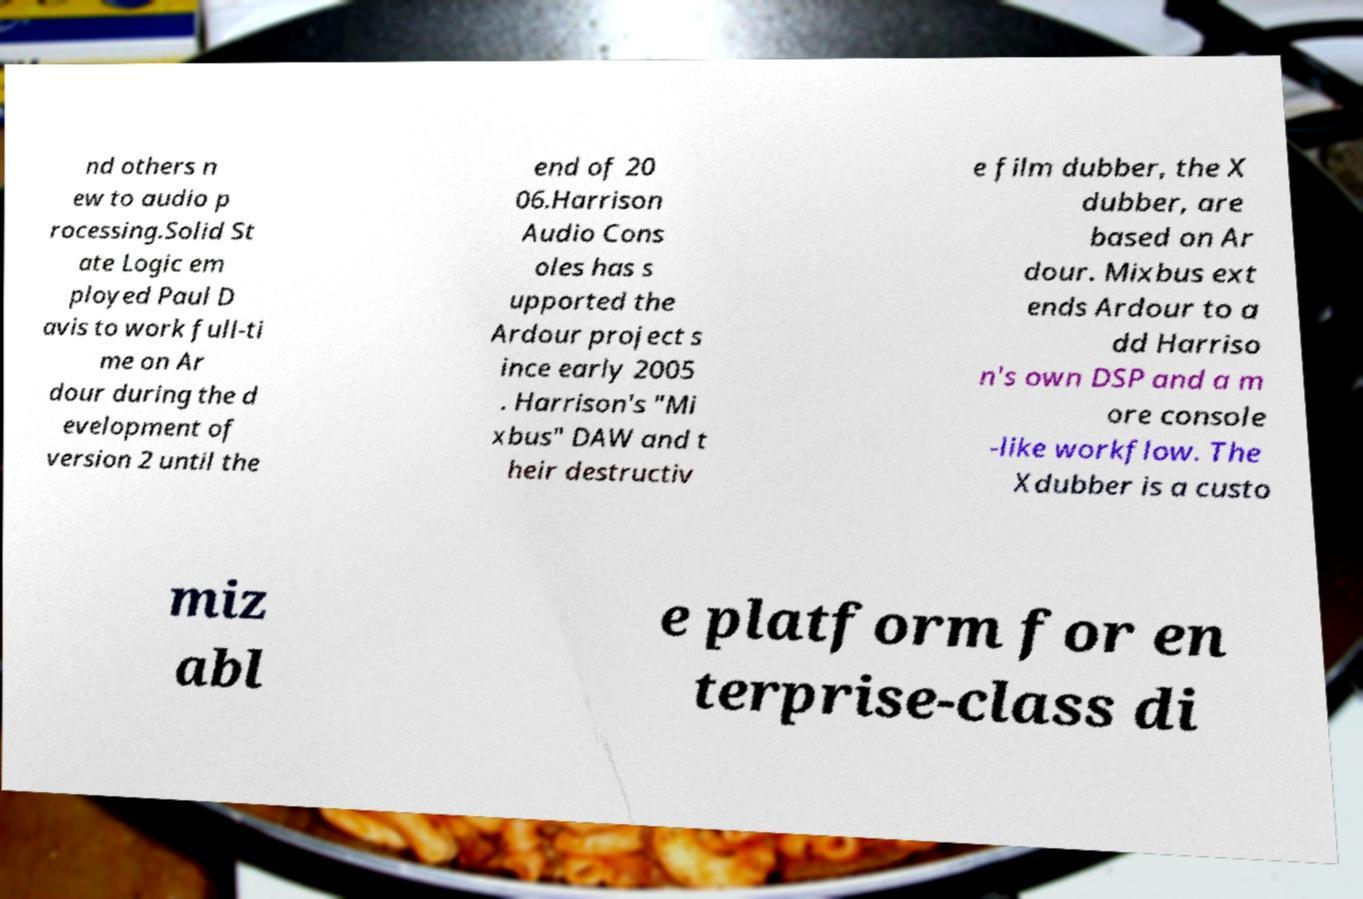Could you extract and type out the text from this image? nd others n ew to audio p rocessing.Solid St ate Logic em ployed Paul D avis to work full-ti me on Ar dour during the d evelopment of version 2 until the end of 20 06.Harrison Audio Cons oles has s upported the Ardour project s ince early 2005 . Harrison's "Mi xbus" DAW and t heir destructiv e film dubber, the X dubber, are based on Ar dour. Mixbus ext ends Ardour to a dd Harriso n's own DSP and a m ore console -like workflow. The Xdubber is a custo miz abl e platform for en terprise-class di 